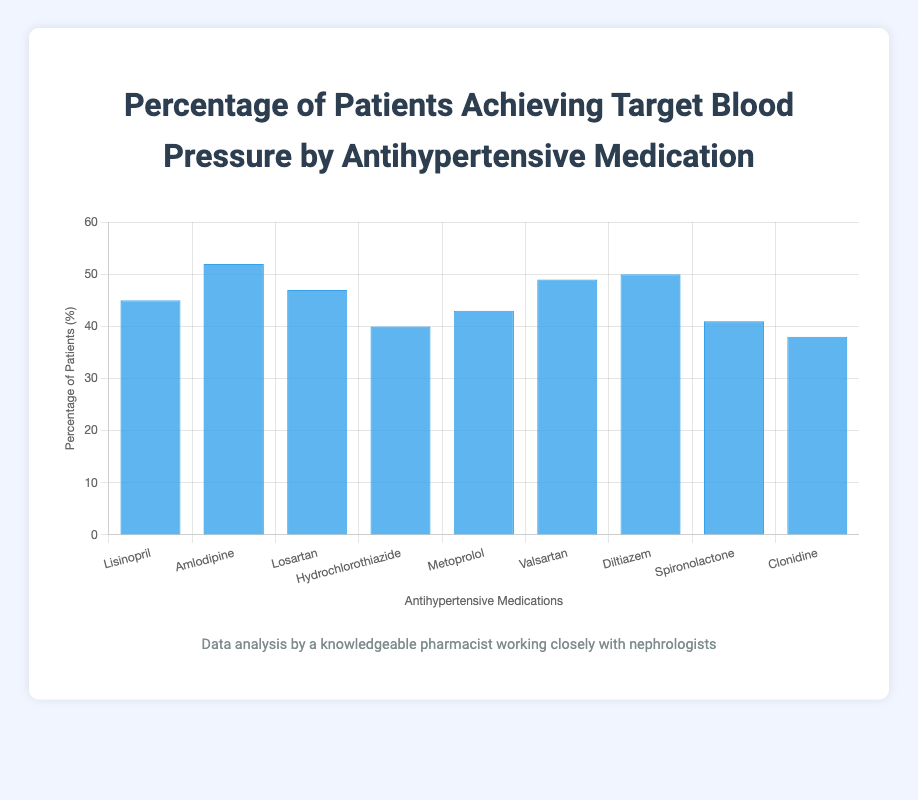What's the most effective medication for achieving target blood pressure? The bar representing Amlodipine is the tallest among all medications, which means it has the highest percentage of patients achieving target blood pressure at 52%
Answer: Amlodipine How much lower is the percentage for Clonidine compared to Diltiazem? Subtract the percentage of patients achieving target blood pressure with Clonidine (38%) from that of Diltiazem (50%)
Answer: 12% Which medication has the lowest percentage of patients achieving target blood pressure? The shortest bar corresponds to Clonidine, with a percentage of 38%
Answer: Clonidine Compare the percentages of patients achieving target blood pressure between Losartan and Metoprolol. Losartan has a percentage of 47%, while Metoprolol has 43%. Thus, Losartan has a higher percentage than Metoprolol by 4%
Answer: Losartan has 4% more than Metoprolol What's the average percentage of all medications achieving target blood pressure? Sum all percentages (45 + 52 + 47 + 40 + 43 + 49 + 50 + 41 + 38 = 405) and divide by the number of medications (9)
Answer: 45% How much higher is the percentage for Valsartan compared to Hydrochlorothiazide? Subtract the percentage of patients achieving target blood pressure with Hydrochlorothiazide (40%) from Valsartan (49%)
Answer: 9% Which medications have their percentages higher than the average? The average calculated is 45%. The bars above this average line are Amlodipine (52%), Losartan (47%), Valsartan (49%), and Diltiazem (50%)
Answer: Amlodipine, Losartan, Valsartan, Diltiazem Compare Diltiazem and Lisinopril in terms of their efficacy in achieving target blood pressure. Diltiazem has a percentage of 50% while Lisinopril has 45%, so Diltiazem is more effective by 5%
Answer: Diltiazem is 5% more effective What’s the difference in percentage between the most and least effective medications? The most effective is Amlodipine (52%) and the least is Clonidine (38%). Subtracting Clonidine's percentage from Amlodipine's
Answer: 14% What's the median percentage of patients achieving target blood pressure across all medications? Arrange all percentages in ascending order (38, 40, 41, 43, 45, 47, 49, 50, 52). The middle value (5th) is 45%
Answer: 45% 